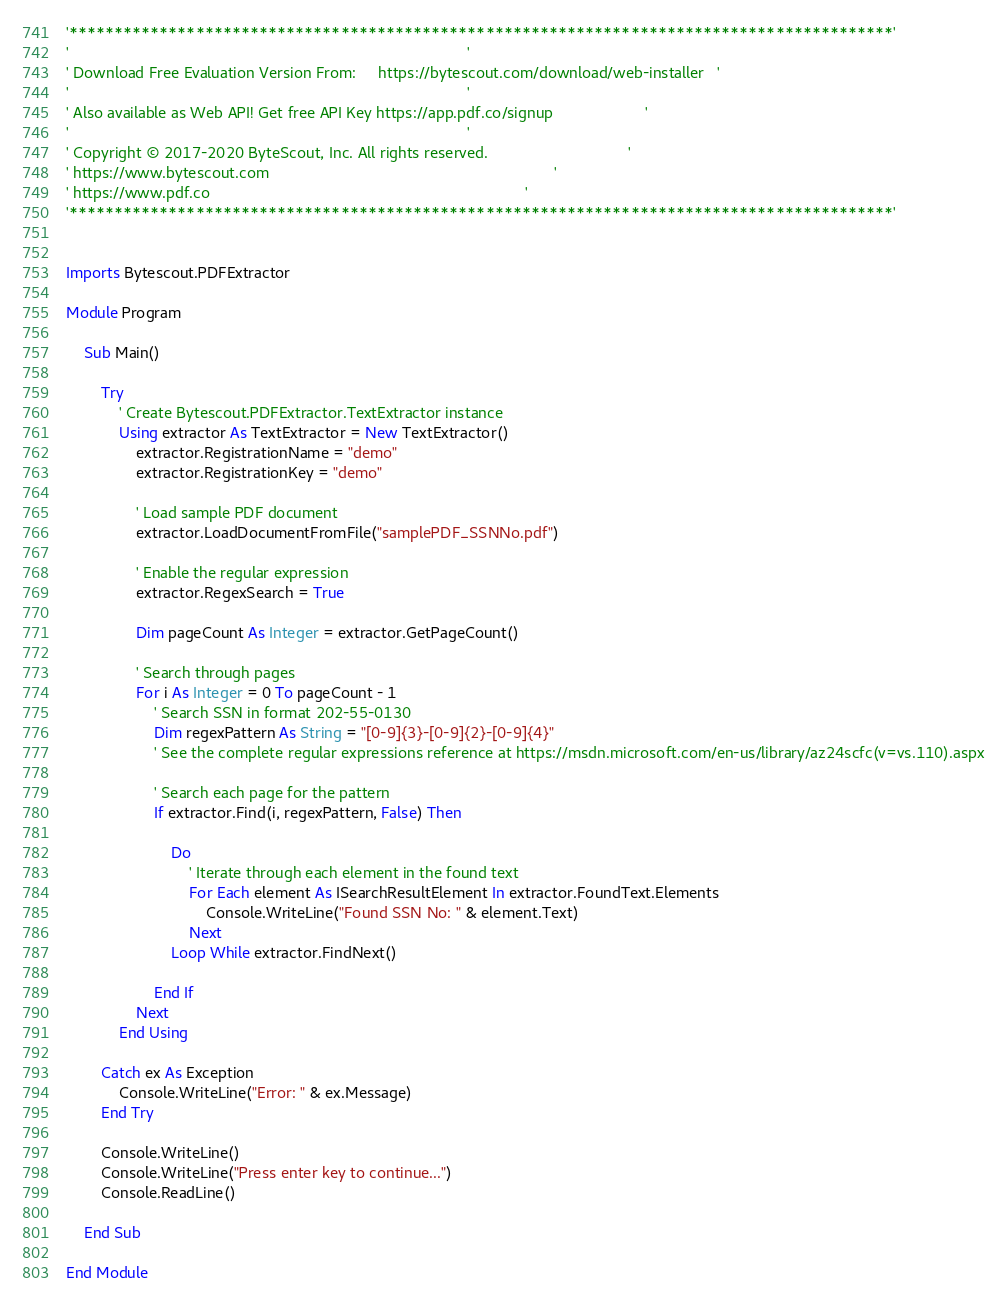Convert code to text. <code><loc_0><loc_0><loc_500><loc_500><_VisualBasic_>'*******************************************************************************************'
'                                                                                           '
' Download Free Evaluation Version From:     https://bytescout.com/download/web-installer   '
'                                                                                           '
' Also available as Web API! Get free API Key https://app.pdf.co/signup                     '
'                                                                                           '
' Copyright © 2017-2020 ByteScout, Inc. All rights reserved.                                '
' https://www.bytescout.com                                                                 '
' https://www.pdf.co                                                                        '
'*******************************************************************************************'


Imports Bytescout.PDFExtractor

Module Program

    Sub Main()

        Try
            ' Create Bytescout.PDFExtractor.TextExtractor instance
            Using extractor As TextExtractor = New TextExtractor()
                extractor.RegistrationName = "demo"
                extractor.RegistrationKey = "demo"

                ' Load sample PDF document
                extractor.LoadDocumentFromFile("samplePDF_SSNNo.pdf")

                ' Enable the regular expression 
                extractor.RegexSearch = True

                Dim pageCount As Integer = extractor.GetPageCount()

                ' Search through pages
                For i As Integer = 0 To pageCount - 1
                    ' Search SSN in format 202-55-0130
                    Dim regexPattern As String = "[0-9]{3}-[0-9]{2}-[0-9]{4}"
                    ' See the complete regular expressions reference at https://msdn.microsoft.com/en-us/library/az24scfc(v=vs.110).aspx

                    ' Search each page for the pattern
                    If extractor.Find(i, regexPattern, False) Then

                        Do
                            ' Iterate through each element in the found text
                            For Each element As ISearchResultElement In extractor.FoundText.Elements
                                Console.WriteLine("Found SSN No: " & element.Text)
                            Next
                        Loop While extractor.FindNext()

                    End If
                Next
            End Using

        Catch ex As Exception
            Console.WriteLine("Error: " & ex.Message)
        End Try

        Console.WriteLine()
        Console.WriteLine("Press enter key to continue...")
        Console.ReadLine()

    End Sub

End Module
</code> 